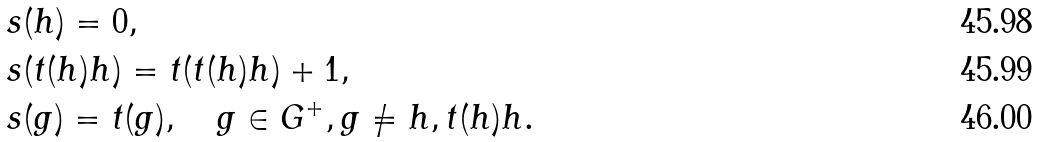Convert formula to latex. <formula><loc_0><loc_0><loc_500><loc_500>& s ( h ) = 0 , \\ & s ( t ( h ) h ) = t ( t ( h ) h ) + 1 , \\ & s ( g ) = t ( g ) , \quad g \in G ^ { + } , g \neq h , t ( h ) h .</formula> 